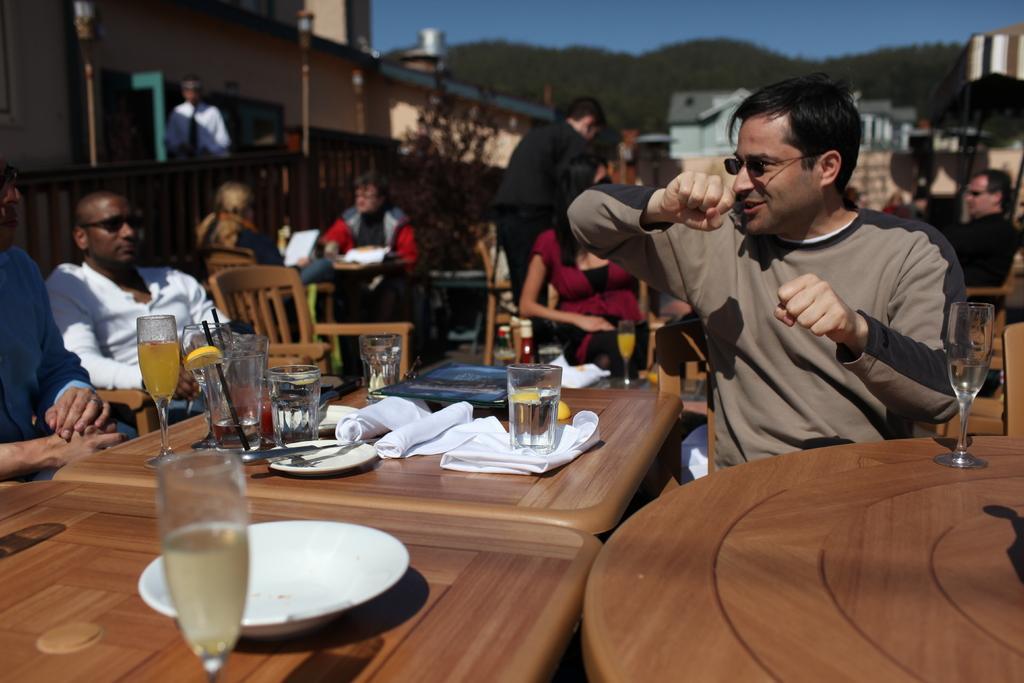In one or two sentences, can you explain what this image depicts? On the right a man is sitting on the chair wearing spectacles in the middle there are wine glasses and glasses on the table. 